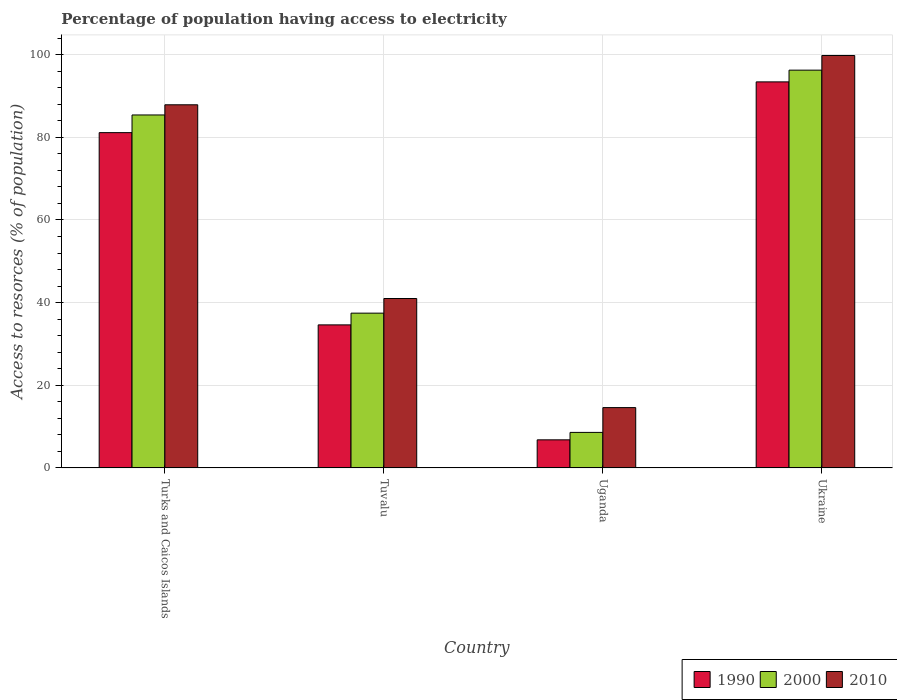How many different coloured bars are there?
Provide a short and direct response. 3. How many groups of bars are there?
Offer a terse response. 4. Are the number of bars per tick equal to the number of legend labels?
Ensure brevity in your answer.  Yes. Are the number of bars on each tick of the X-axis equal?
Your answer should be compact. Yes. How many bars are there on the 4th tick from the left?
Provide a short and direct response. 3. How many bars are there on the 4th tick from the right?
Your response must be concise. 3. What is the label of the 2nd group of bars from the left?
Provide a short and direct response. Tuvalu. What is the percentage of population having access to electricity in 2010 in Uganda?
Your response must be concise. 14.6. Across all countries, what is the maximum percentage of population having access to electricity in 1990?
Your answer should be compact. 93.42. In which country was the percentage of population having access to electricity in 2010 maximum?
Offer a terse response. Ukraine. In which country was the percentage of population having access to electricity in 1990 minimum?
Your answer should be compact. Uganda. What is the total percentage of population having access to electricity in 2000 in the graph?
Your answer should be very brief. 227.72. What is the difference between the percentage of population having access to electricity in 1990 in Turks and Caicos Islands and that in Ukraine?
Give a very brief answer. -12.28. What is the difference between the percentage of population having access to electricity in 2010 in Uganda and the percentage of population having access to electricity in 2000 in Turks and Caicos Islands?
Your answer should be very brief. -70.81. What is the average percentage of population having access to electricity in 2000 per country?
Your answer should be compact. 56.93. What is the difference between the percentage of population having access to electricity of/in 2000 and percentage of population having access to electricity of/in 2010 in Turks and Caicos Islands?
Make the answer very short. -2.46. In how many countries, is the percentage of population having access to electricity in 2010 greater than 20 %?
Provide a short and direct response. 3. What is the ratio of the percentage of population having access to electricity in 1990 in Turks and Caicos Islands to that in Tuvalu?
Your answer should be compact. 2.34. What is the difference between the highest and the second highest percentage of population having access to electricity in 1990?
Make the answer very short. 46.52. What is the difference between the highest and the lowest percentage of population having access to electricity in 2000?
Make the answer very short. 87.66. What does the 2nd bar from the left in Tuvalu represents?
Make the answer very short. 2000. Are the values on the major ticks of Y-axis written in scientific E-notation?
Provide a succinct answer. No. Does the graph contain any zero values?
Your answer should be very brief. No. How many legend labels are there?
Provide a succinct answer. 3. How are the legend labels stacked?
Make the answer very short. Horizontal. What is the title of the graph?
Offer a very short reply. Percentage of population having access to electricity. Does "1989" appear as one of the legend labels in the graph?
Offer a very short reply. No. What is the label or title of the X-axis?
Offer a terse response. Country. What is the label or title of the Y-axis?
Offer a terse response. Access to resorces (% of population). What is the Access to resorces (% of population) of 1990 in Turks and Caicos Islands?
Your answer should be compact. 81.14. What is the Access to resorces (% of population) of 2000 in Turks and Caicos Islands?
Your answer should be compact. 85.41. What is the Access to resorces (% of population) in 2010 in Turks and Caicos Islands?
Your response must be concise. 87.87. What is the Access to resorces (% of population) in 1990 in Tuvalu?
Your answer should be very brief. 34.62. What is the Access to resorces (% of population) of 2000 in Tuvalu?
Your answer should be compact. 37.46. What is the Access to resorces (% of population) of 2010 in Tuvalu?
Provide a short and direct response. 41. What is the Access to resorces (% of population) in 2010 in Uganda?
Ensure brevity in your answer.  14.6. What is the Access to resorces (% of population) of 1990 in Ukraine?
Ensure brevity in your answer.  93.42. What is the Access to resorces (% of population) of 2000 in Ukraine?
Offer a terse response. 96.26. What is the Access to resorces (% of population) of 2010 in Ukraine?
Give a very brief answer. 99.8. Across all countries, what is the maximum Access to resorces (% of population) in 1990?
Provide a succinct answer. 93.42. Across all countries, what is the maximum Access to resorces (% of population) in 2000?
Your answer should be very brief. 96.26. Across all countries, what is the maximum Access to resorces (% of population) in 2010?
Your response must be concise. 99.8. Across all countries, what is the minimum Access to resorces (% of population) in 1990?
Your answer should be very brief. 6.8. Across all countries, what is the minimum Access to resorces (% of population) in 2000?
Your response must be concise. 8.6. Across all countries, what is the minimum Access to resorces (% of population) of 2010?
Ensure brevity in your answer.  14.6. What is the total Access to resorces (% of population) in 1990 in the graph?
Provide a short and direct response. 215.97. What is the total Access to resorces (% of population) of 2000 in the graph?
Give a very brief answer. 227.72. What is the total Access to resorces (% of population) in 2010 in the graph?
Make the answer very short. 243.27. What is the difference between the Access to resorces (% of population) of 1990 in Turks and Caicos Islands and that in Tuvalu?
Ensure brevity in your answer.  46.52. What is the difference between the Access to resorces (% of population) of 2000 in Turks and Caicos Islands and that in Tuvalu?
Provide a short and direct response. 47.96. What is the difference between the Access to resorces (% of population) of 2010 in Turks and Caicos Islands and that in Tuvalu?
Keep it short and to the point. 46.87. What is the difference between the Access to resorces (% of population) of 1990 in Turks and Caicos Islands and that in Uganda?
Ensure brevity in your answer.  74.34. What is the difference between the Access to resorces (% of population) of 2000 in Turks and Caicos Islands and that in Uganda?
Your answer should be compact. 76.81. What is the difference between the Access to resorces (% of population) in 2010 in Turks and Caicos Islands and that in Uganda?
Ensure brevity in your answer.  73.27. What is the difference between the Access to resorces (% of population) in 1990 in Turks and Caicos Islands and that in Ukraine?
Your response must be concise. -12.28. What is the difference between the Access to resorces (% of population) of 2000 in Turks and Caicos Islands and that in Ukraine?
Make the answer very short. -10.84. What is the difference between the Access to resorces (% of population) in 2010 in Turks and Caicos Islands and that in Ukraine?
Ensure brevity in your answer.  -11.93. What is the difference between the Access to resorces (% of population) in 1990 in Tuvalu and that in Uganda?
Make the answer very short. 27.82. What is the difference between the Access to resorces (% of population) in 2000 in Tuvalu and that in Uganda?
Offer a very short reply. 28.86. What is the difference between the Access to resorces (% of population) of 2010 in Tuvalu and that in Uganda?
Give a very brief answer. 26.4. What is the difference between the Access to resorces (% of population) of 1990 in Tuvalu and that in Ukraine?
Your answer should be compact. -58.8. What is the difference between the Access to resorces (% of population) of 2000 in Tuvalu and that in Ukraine?
Make the answer very short. -58.8. What is the difference between the Access to resorces (% of population) of 2010 in Tuvalu and that in Ukraine?
Your answer should be compact. -58.8. What is the difference between the Access to resorces (% of population) in 1990 in Uganda and that in Ukraine?
Give a very brief answer. -86.62. What is the difference between the Access to resorces (% of population) in 2000 in Uganda and that in Ukraine?
Provide a succinct answer. -87.66. What is the difference between the Access to resorces (% of population) in 2010 in Uganda and that in Ukraine?
Offer a very short reply. -85.2. What is the difference between the Access to resorces (% of population) in 1990 in Turks and Caicos Islands and the Access to resorces (% of population) in 2000 in Tuvalu?
Your answer should be very brief. 43.68. What is the difference between the Access to resorces (% of population) of 1990 in Turks and Caicos Islands and the Access to resorces (% of population) of 2010 in Tuvalu?
Provide a succinct answer. 40.14. What is the difference between the Access to resorces (% of population) in 2000 in Turks and Caicos Islands and the Access to resorces (% of population) in 2010 in Tuvalu?
Your answer should be very brief. 44.41. What is the difference between the Access to resorces (% of population) of 1990 in Turks and Caicos Islands and the Access to resorces (% of population) of 2000 in Uganda?
Provide a short and direct response. 72.54. What is the difference between the Access to resorces (% of population) in 1990 in Turks and Caicos Islands and the Access to resorces (% of population) in 2010 in Uganda?
Offer a very short reply. 66.54. What is the difference between the Access to resorces (% of population) of 2000 in Turks and Caicos Islands and the Access to resorces (% of population) of 2010 in Uganda?
Your answer should be compact. 70.81. What is the difference between the Access to resorces (% of population) in 1990 in Turks and Caicos Islands and the Access to resorces (% of population) in 2000 in Ukraine?
Give a very brief answer. -15.12. What is the difference between the Access to resorces (% of population) in 1990 in Turks and Caicos Islands and the Access to resorces (% of population) in 2010 in Ukraine?
Provide a short and direct response. -18.66. What is the difference between the Access to resorces (% of population) in 2000 in Turks and Caicos Islands and the Access to resorces (% of population) in 2010 in Ukraine?
Keep it short and to the point. -14.39. What is the difference between the Access to resorces (% of population) in 1990 in Tuvalu and the Access to resorces (% of population) in 2000 in Uganda?
Ensure brevity in your answer.  26.02. What is the difference between the Access to resorces (% of population) in 1990 in Tuvalu and the Access to resorces (% of population) in 2010 in Uganda?
Offer a terse response. 20.02. What is the difference between the Access to resorces (% of population) of 2000 in Tuvalu and the Access to resorces (% of population) of 2010 in Uganda?
Offer a very short reply. 22.86. What is the difference between the Access to resorces (% of population) of 1990 in Tuvalu and the Access to resorces (% of population) of 2000 in Ukraine?
Your response must be concise. -61.64. What is the difference between the Access to resorces (% of population) of 1990 in Tuvalu and the Access to resorces (% of population) of 2010 in Ukraine?
Keep it short and to the point. -65.18. What is the difference between the Access to resorces (% of population) in 2000 in Tuvalu and the Access to resorces (% of population) in 2010 in Ukraine?
Give a very brief answer. -62.34. What is the difference between the Access to resorces (% of population) in 1990 in Uganda and the Access to resorces (% of population) in 2000 in Ukraine?
Make the answer very short. -89.46. What is the difference between the Access to resorces (% of population) in 1990 in Uganda and the Access to resorces (% of population) in 2010 in Ukraine?
Give a very brief answer. -93. What is the difference between the Access to resorces (% of population) in 2000 in Uganda and the Access to resorces (% of population) in 2010 in Ukraine?
Your answer should be very brief. -91.2. What is the average Access to resorces (% of population) of 1990 per country?
Give a very brief answer. 53.99. What is the average Access to resorces (% of population) in 2000 per country?
Your answer should be very brief. 56.93. What is the average Access to resorces (% of population) of 2010 per country?
Offer a very short reply. 60.82. What is the difference between the Access to resorces (% of population) of 1990 and Access to resorces (% of population) of 2000 in Turks and Caicos Islands?
Your answer should be compact. -4.28. What is the difference between the Access to resorces (% of population) of 1990 and Access to resorces (% of population) of 2010 in Turks and Caicos Islands?
Your response must be concise. -6.74. What is the difference between the Access to resorces (% of population) of 2000 and Access to resorces (% of population) of 2010 in Turks and Caicos Islands?
Offer a terse response. -2.46. What is the difference between the Access to resorces (% of population) in 1990 and Access to resorces (% of population) in 2000 in Tuvalu?
Provide a short and direct response. -2.84. What is the difference between the Access to resorces (% of population) in 1990 and Access to resorces (% of population) in 2010 in Tuvalu?
Ensure brevity in your answer.  -6.38. What is the difference between the Access to resorces (% of population) of 2000 and Access to resorces (% of population) of 2010 in Tuvalu?
Ensure brevity in your answer.  -3.54. What is the difference between the Access to resorces (% of population) in 1990 and Access to resorces (% of population) in 2000 in Uganda?
Ensure brevity in your answer.  -1.8. What is the difference between the Access to resorces (% of population) of 2000 and Access to resorces (% of population) of 2010 in Uganda?
Keep it short and to the point. -6. What is the difference between the Access to resorces (% of population) in 1990 and Access to resorces (% of population) in 2000 in Ukraine?
Make the answer very short. -2.84. What is the difference between the Access to resorces (% of population) of 1990 and Access to resorces (% of population) of 2010 in Ukraine?
Ensure brevity in your answer.  -6.38. What is the difference between the Access to resorces (% of population) in 2000 and Access to resorces (% of population) in 2010 in Ukraine?
Offer a terse response. -3.54. What is the ratio of the Access to resorces (% of population) of 1990 in Turks and Caicos Islands to that in Tuvalu?
Offer a terse response. 2.34. What is the ratio of the Access to resorces (% of population) of 2000 in Turks and Caicos Islands to that in Tuvalu?
Offer a terse response. 2.28. What is the ratio of the Access to resorces (% of population) of 2010 in Turks and Caicos Islands to that in Tuvalu?
Give a very brief answer. 2.14. What is the ratio of the Access to resorces (% of population) in 1990 in Turks and Caicos Islands to that in Uganda?
Ensure brevity in your answer.  11.93. What is the ratio of the Access to resorces (% of population) of 2000 in Turks and Caicos Islands to that in Uganda?
Offer a very short reply. 9.93. What is the ratio of the Access to resorces (% of population) of 2010 in Turks and Caicos Islands to that in Uganda?
Ensure brevity in your answer.  6.02. What is the ratio of the Access to resorces (% of population) in 1990 in Turks and Caicos Islands to that in Ukraine?
Your answer should be compact. 0.87. What is the ratio of the Access to resorces (% of population) of 2000 in Turks and Caicos Islands to that in Ukraine?
Provide a short and direct response. 0.89. What is the ratio of the Access to resorces (% of population) of 2010 in Turks and Caicos Islands to that in Ukraine?
Provide a succinct answer. 0.88. What is the ratio of the Access to resorces (% of population) of 1990 in Tuvalu to that in Uganda?
Your answer should be compact. 5.09. What is the ratio of the Access to resorces (% of population) in 2000 in Tuvalu to that in Uganda?
Your answer should be compact. 4.36. What is the ratio of the Access to resorces (% of population) in 2010 in Tuvalu to that in Uganda?
Your response must be concise. 2.81. What is the ratio of the Access to resorces (% of population) in 1990 in Tuvalu to that in Ukraine?
Offer a very short reply. 0.37. What is the ratio of the Access to resorces (% of population) of 2000 in Tuvalu to that in Ukraine?
Ensure brevity in your answer.  0.39. What is the ratio of the Access to resorces (% of population) of 2010 in Tuvalu to that in Ukraine?
Ensure brevity in your answer.  0.41. What is the ratio of the Access to resorces (% of population) of 1990 in Uganda to that in Ukraine?
Make the answer very short. 0.07. What is the ratio of the Access to resorces (% of population) in 2000 in Uganda to that in Ukraine?
Provide a succinct answer. 0.09. What is the ratio of the Access to resorces (% of population) in 2010 in Uganda to that in Ukraine?
Your response must be concise. 0.15. What is the difference between the highest and the second highest Access to resorces (% of population) of 1990?
Provide a short and direct response. 12.28. What is the difference between the highest and the second highest Access to resorces (% of population) in 2000?
Offer a very short reply. 10.84. What is the difference between the highest and the second highest Access to resorces (% of population) in 2010?
Provide a short and direct response. 11.93. What is the difference between the highest and the lowest Access to resorces (% of population) of 1990?
Provide a succinct answer. 86.62. What is the difference between the highest and the lowest Access to resorces (% of population) in 2000?
Give a very brief answer. 87.66. What is the difference between the highest and the lowest Access to resorces (% of population) of 2010?
Keep it short and to the point. 85.2. 